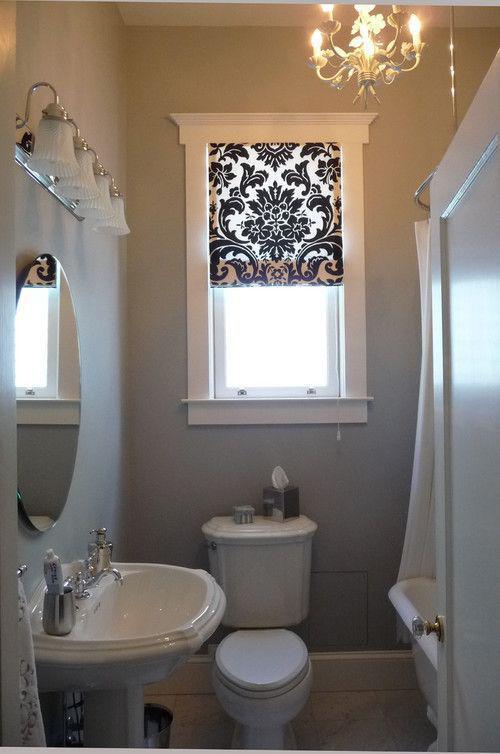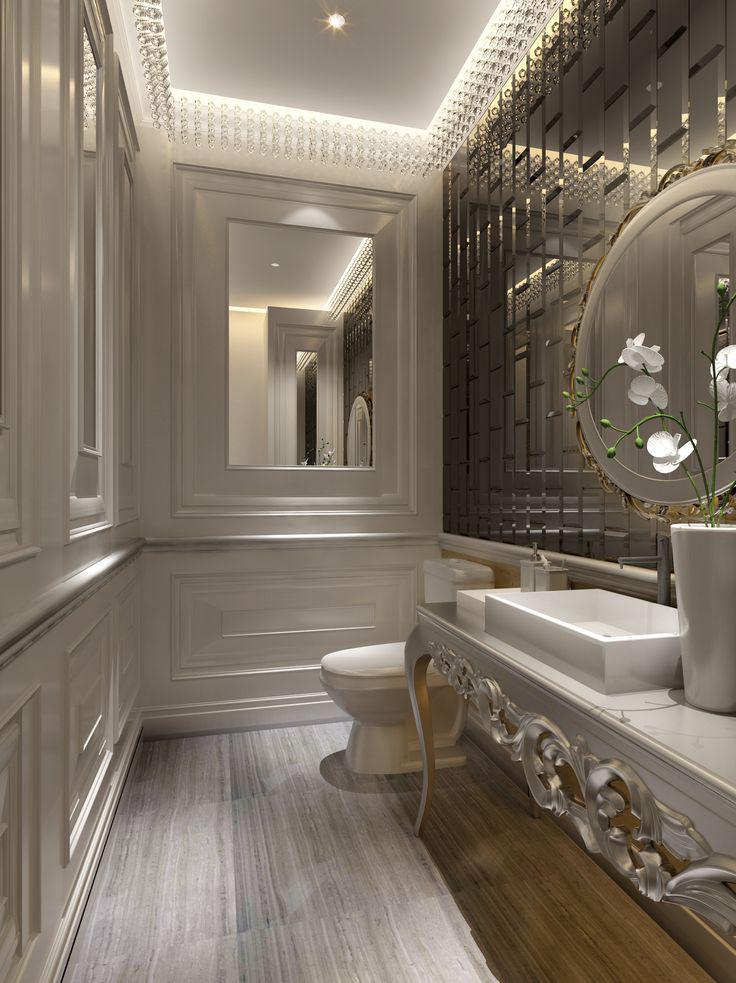The first image is the image on the left, the second image is the image on the right. Evaluate the accuracy of this statement regarding the images: "In one image, a panel of the shower enclosure has a lower section that is an extension of the bathroom wall and an upper section that is a clear glass window showing the shower head.". Is it true? Answer yes or no. No. The first image is the image on the left, the second image is the image on the right. Given the left and right images, does the statement "An image shows a paned window near a sink with one spout and separate faucet handles." hold true? Answer yes or no. No. 